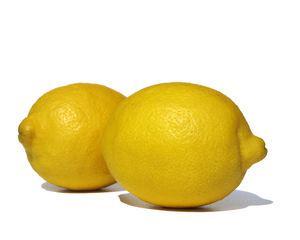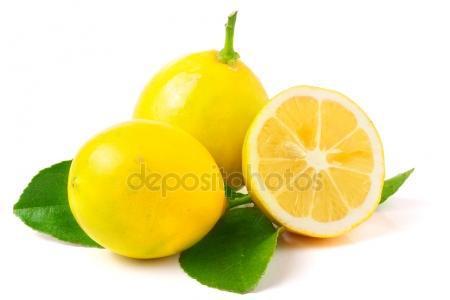The first image is the image on the left, the second image is the image on the right. Examine the images to the left and right. Is the description "There is one half of a lemon in one of the images." accurate? Answer yes or no. Yes. The first image is the image on the left, the second image is the image on the right. Evaluate the accuracy of this statement regarding the images: "One image contains only two whole lemons with peels intact.". Is it true? Answer yes or no. Yes. The first image is the image on the left, the second image is the image on the right. Evaluate the accuracy of this statement regarding the images: "The right image contains no more than three lemons.". Is it true? Answer yes or no. Yes. 